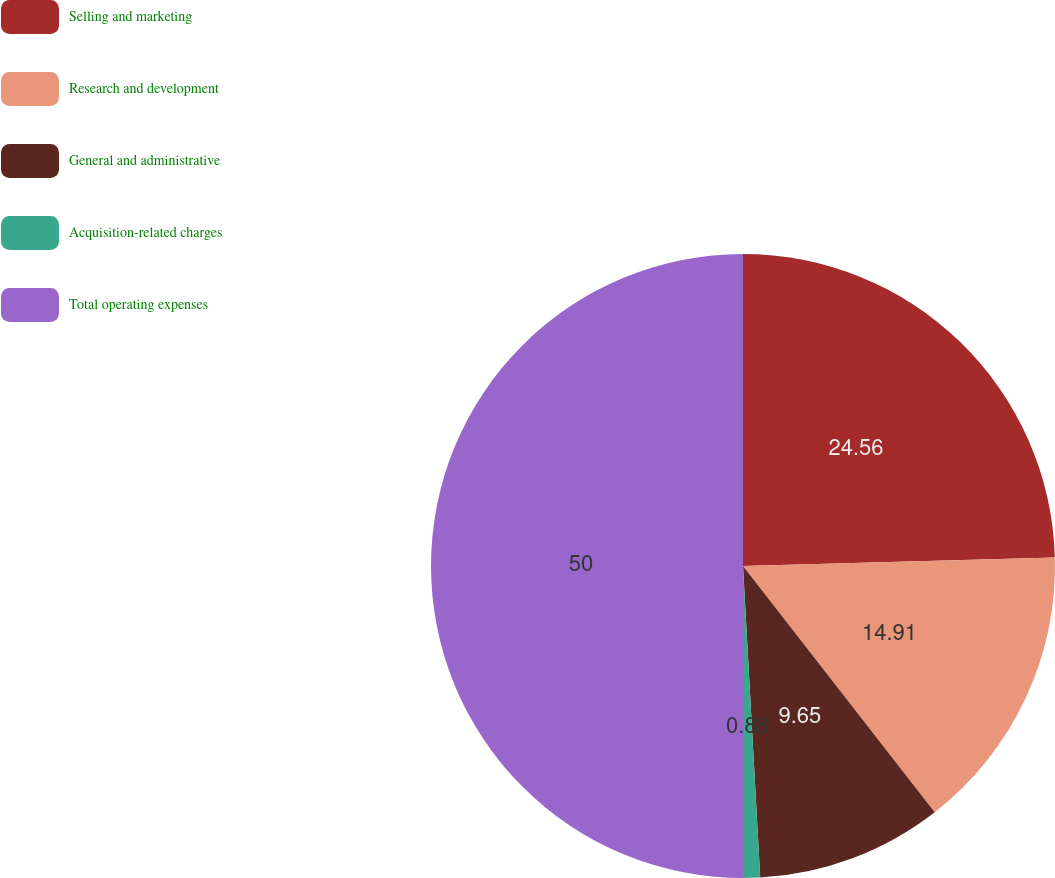<chart> <loc_0><loc_0><loc_500><loc_500><pie_chart><fcel>Selling and marketing<fcel>Research and development<fcel>General and administrative<fcel>Acquisition-related charges<fcel>Total operating expenses<nl><fcel>24.56%<fcel>14.91%<fcel>9.65%<fcel>0.88%<fcel>50.0%<nl></chart> 